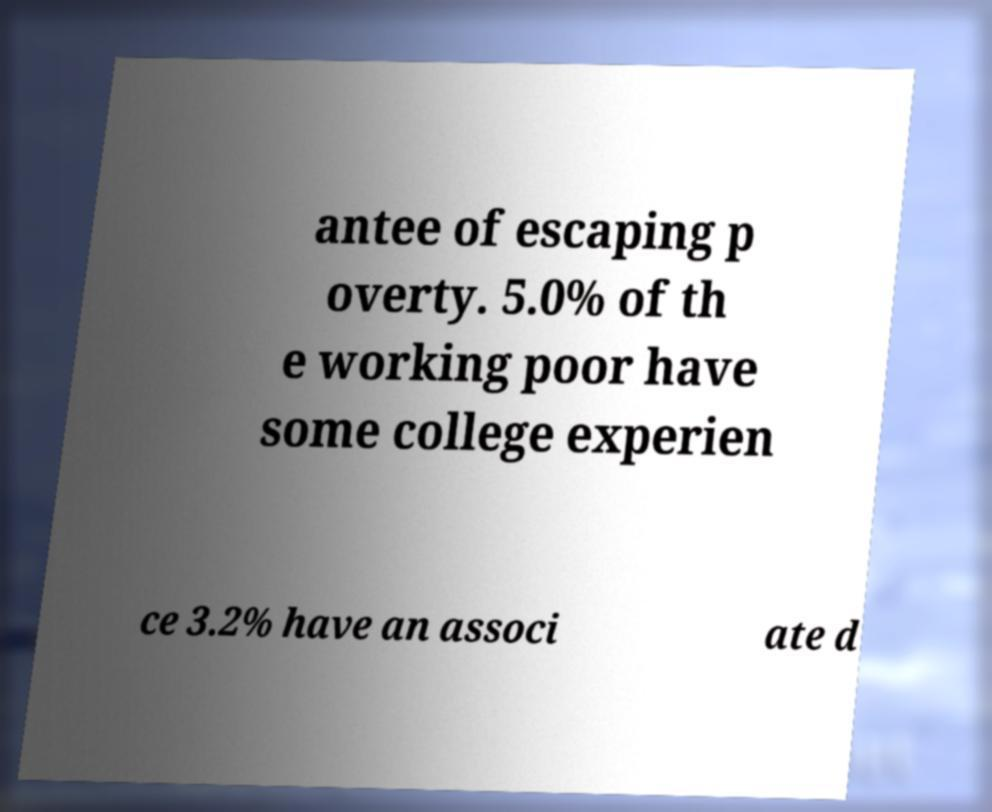Please read and relay the text visible in this image. What does it say? antee of escaping p overty. 5.0% of th e working poor have some college experien ce 3.2% have an associ ate d 